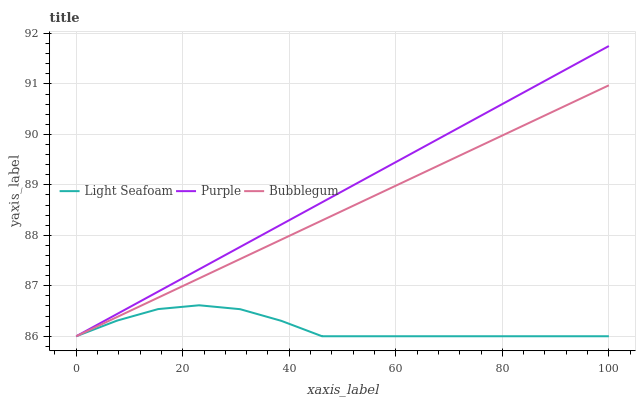Does Bubblegum have the minimum area under the curve?
Answer yes or no. No. Does Bubblegum have the maximum area under the curve?
Answer yes or no. No. Is Bubblegum the smoothest?
Answer yes or no. No. Is Bubblegum the roughest?
Answer yes or no. No. Does Bubblegum have the highest value?
Answer yes or no. No. 